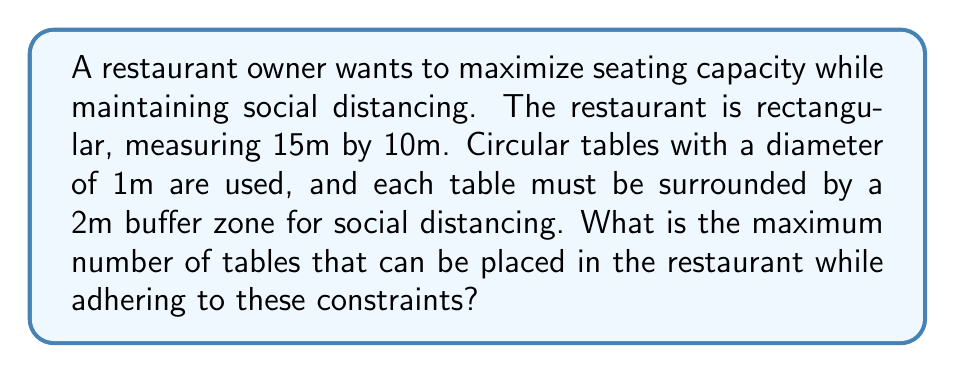Can you solve this math problem? Let's approach this step-by-step:

1) First, we need to determine the effective area each table occupies, including its buffer zone:
   - Table diameter: 1m
   - Buffer zone: 2m on each side
   - Total diameter of occupied space: 1m + 2m + 2m = 5m
   - Radius of occupied space: 2.5m
   - Area of occupied space: $A = \pi r^2 = \pi (2.5)^2 = 19.63 \text{ m}^2$

2) Now, let's calculate the total area of the restaurant:
   $A_{restaurant} = 15\text{ m} \times 10\text{ m} = 150 \text{ m}^2$

3) To find the maximum number of tables, we divide the restaurant area by the area each table occupies:
   $N_{tables} = \frac{A_{restaurant}}{A_{table}} = \frac{150}{19.63} \approx 7.64$

4) Since we can't have partial tables, we round down to the nearest whole number:
   $N_{tables} = 7$

5) To verify, we can calculate the total area occupied by 7 tables:
   $7 \times 19.63 \text{ m}^2 = 137.41 \text{ m}^2$
   This is less than the restaurant's area of 150 m², confirming that 7 tables will fit.

6) Adding an 8th table would require:
   $8 \times 19.63 \text{ m}^2 = 157.04 \text{ m}^2$
   This exceeds the restaurant's area, so 8 tables won't fit.

Therefore, the maximum number of tables that can be placed in the restaurant while adhering to social distancing constraints is 7.
Answer: 7 tables 